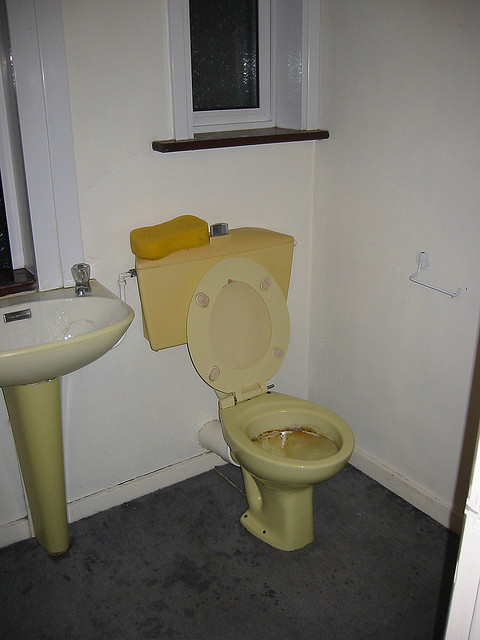<image>What reflective object is on the wall? I am not sure what reflective object is on the wall. It could be a mirror or window. What reflective object is on the wall? I am not sure what reflective object is on the wall. It can be seen mirror or window. 